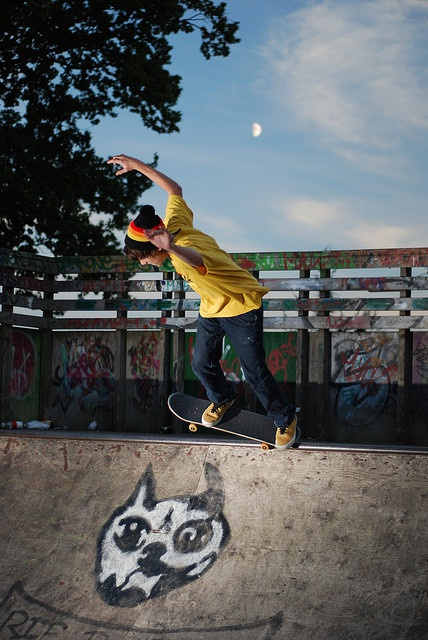Describe the objects in this image and their specific colors. I can see people in black, olive, and maroon tones and skateboard in black, gray, and tan tones in this image. 